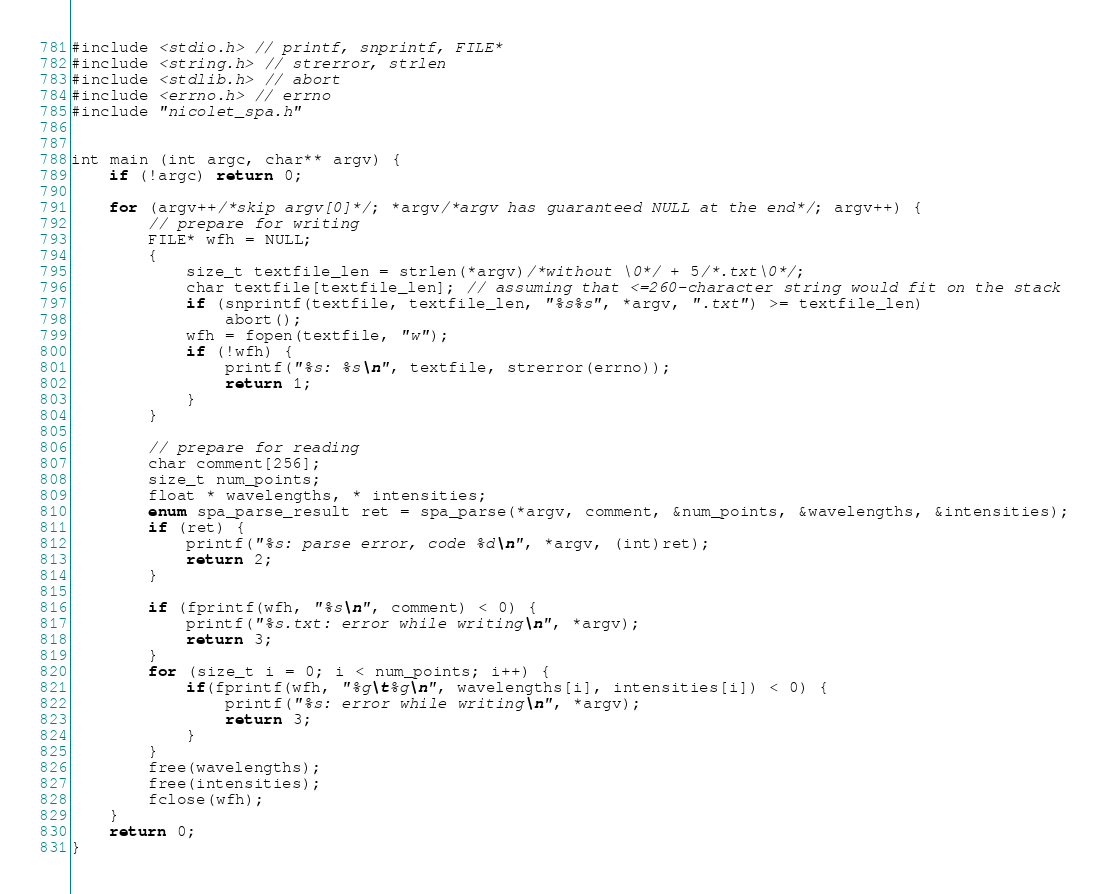Convert code to text. <code><loc_0><loc_0><loc_500><loc_500><_C_>#include <stdio.h> // printf, snprintf, FILE*
#include <string.h> // strerror, strlen
#include <stdlib.h> // abort
#include <errno.h> // errno
#include "nicolet_spa.h"


int main (int argc, char** argv) {
	if (!argc) return 0;

	for (argv++/*skip argv[0]*/; *argv/*argv has guaranteed NULL at the end*/; argv++) {
		// prepare for writing
		FILE* wfh = NULL;
		{
			size_t textfile_len = strlen(*argv)/*without \0*/ + 5/*.txt\0*/;
			char textfile[textfile_len]; // assuming that <=260-character string would fit on the stack
			if (snprintf(textfile, textfile_len, "%s%s", *argv, ".txt") >= textfile_len)
				abort();
			wfh = fopen(textfile, "w");
			if (!wfh) {
				printf("%s: %s\n", textfile, strerror(errno));
				return 1;
			}
		}

		// prepare for reading
		char comment[256];
		size_t num_points;
		float * wavelengths, * intensities;
		enum spa_parse_result ret = spa_parse(*argv, comment, &num_points, &wavelengths, &intensities);
		if (ret) {
			printf("%s: parse error, code %d\n", *argv, (int)ret);
			return 2;
		}

		if (fprintf(wfh, "%s\n", comment) < 0) {
			printf("%s.txt: error while writing\n", *argv);
			return 3;
		}
		for (size_t i = 0; i < num_points; i++) {
			if(fprintf(wfh, "%g\t%g\n", wavelengths[i], intensities[i]) < 0) {
				printf("%s: error while writing\n", *argv);
				return 3;
			}
		}
		free(wavelengths);
		free(intensities);
		fclose(wfh);
	}
	return 0;
}
</code> 